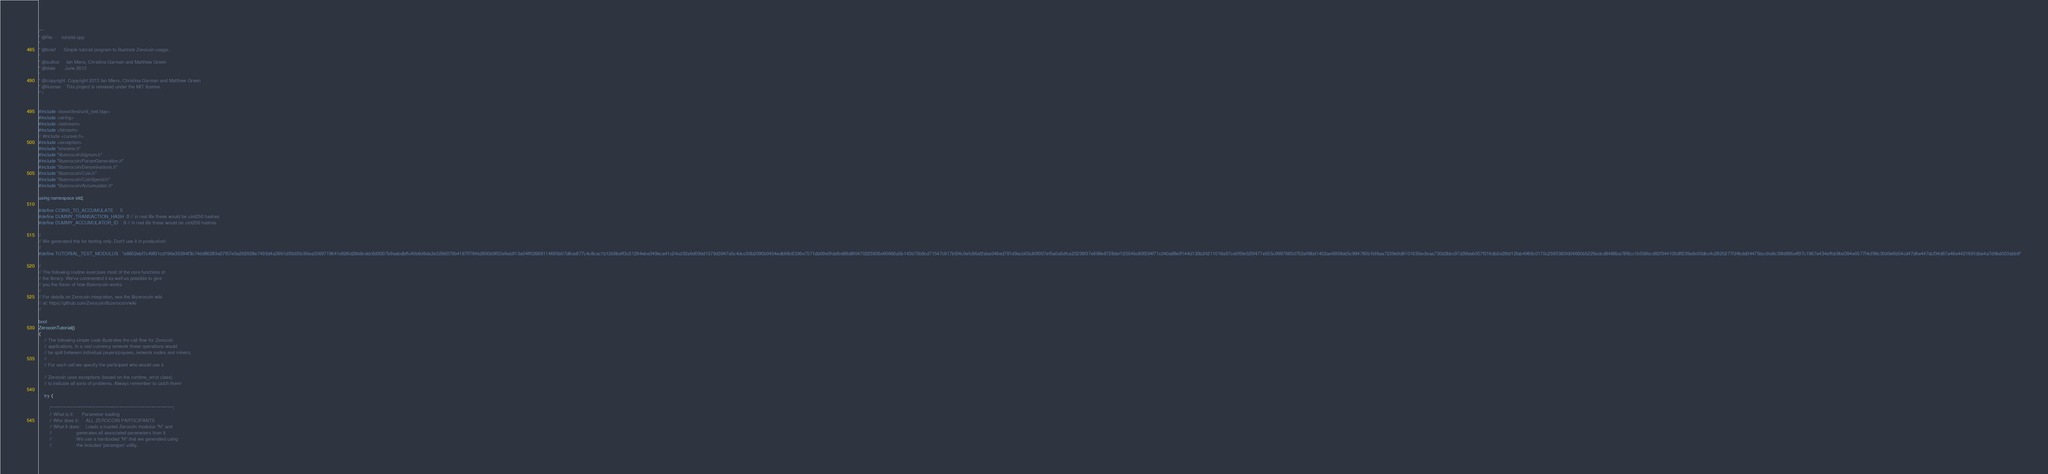<code> <loc_0><loc_0><loc_500><loc_500><_C++_>/**
* @file       tutorial.cpp
*
* @brief      Simple tutorial program to illustrate Zerocoin usage.
*
* @author     Ian Miers, Christina Garman and Matthew Green
* @date       June 2013
*
* @copyright  Copyright 2013 Ian Miers, Christina Garman and Matthew Green
* @license    This project is released under the MIT license.
**/


#include <boost/test/unit_test.hpp>
#include <string>
#include <iostream>
#include <fstream>
// #include <curses.h>
#include <exception>
#include "streams.h"
#include "libzerocoin/bignum.h"
#include "libzerocoin/ParamGeneration.h"
#include "libzerocoin/Denominations.h"
#include "libzerocoin/Coin.h"
#include "libzerocoin/CoinSpend.h"
#include "libzerocoin/Accumulator.h"

using namespace std;

#define COINS_TO_ACCUMULATE     5
#define DUMMY_TRANSACTION_HASH  0 // in real life these would be uint256 hashes
#define DUMMY_ACCUMULATOR_ID    0 // in real life these would be uint256 hashes

//
// We generated this for testing only. Don't use it in production!
//
#define TUTORIAL_TEST_MODULUS   "a8852ebf7c49f01cd196e35394f3b74dd86283a07f57e0a262928e7493d4a3961d93d93c90ea3369719641d626d28b9cddc6d9307b9aabdbffc40b6d6da2e329d079b4187ff784b2893d9f53e9ab913a04ff02668114695b07d8ce877c4c8cac1b12b9beff3c51294ebe349eca41c24cd32a6d09dd1579d3947e5c4dcc30b2090b0454edb98c6336e7571db09e0fdafbd68d8f0470223836e90666a5b143b73b9cd71547c917bf24c0efc86af2eba046ed781d9acb05c80f007ef5a0a5dfca23236f37e698e8728def12554bc80f294f71c040a88eff144d130b24211016a97ce0f5fe520f477e555c9997683d762aff8bd1402ae6938dd5c994780b1bf6aa7239e9d8101630ecfeaa730d2bbc97d39beb057f016db2e28bf12fab4989c0170c2593383fd04660b5229adcd8486ba78f6cc1b558bcd92f344100dff239a8c00dbc4c2825277f24bdd04475bcc9a8c39fd895eff97c1967e434effcb9bd394e0577f4cf98c30d9e6b54cd47d6e447dcf34d67e48e4421691dbe4a7d9bd503abb9"

//
// The following routine exercises most of the core functions of
// the library. We've commented it as well as possible to give
// you the flavor of how libzerocoin works.
//
// For details on Zerocoin integration, see the libzerocoin wiki
// at: https://github.com/Zerocoin/libzerocoin/wiki
//

bool
ZerocoinTutorial()
{
	// The following simple code illustrates the call flow for Zerocoin
	// applications. In a real currency network these operations would
	// be split between individual payers/payees, network nodes and miners.
	//
	// For each call we specify the participant who would use it.

	// Zerocoin uses exceptions (based on the runtime_error class)
	// to indicate all sorts of problems. Always remember to catch them!

	try {

		/********************************************************************/
		// What is it:      Parameter loading
		// Who does it:     ALL ZEROCOIN PARTICIPANTS
		// What it does:    Loads a trusted Zerocoin modulus "N" and
		//                  generates all associated parameters from it.
		//                  We use a hardcoded "N" that we generated using
		//                  the included 'paramgen' utility.</code> 